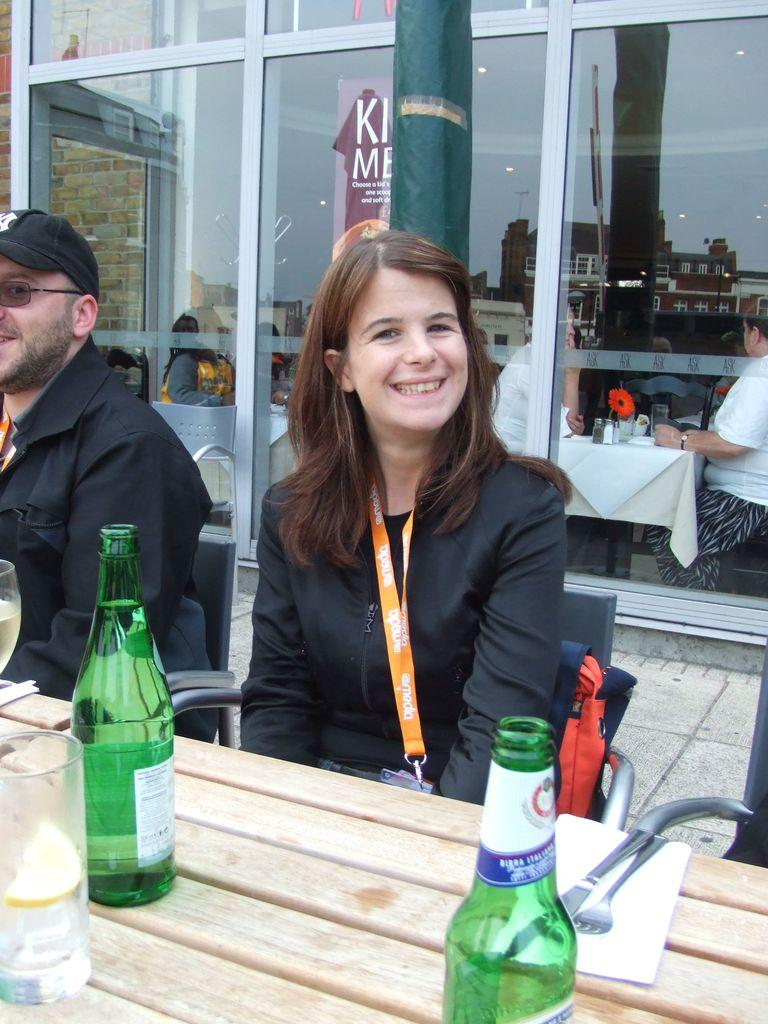What are the two people in the image doing? The woman and man in the image are sitting. Where are they sitting? They are sitting in front of a table. What can be seen on the table in the image? There are bottles on the table. What type of pail is visible in the image? There is no pail present in the image. How many balls are being juggled by the woman in the image? There are no balls or any indication of juggling in the image. What type of seed is being planted by the man in the image? There is no seed or planting activity depicted in the image. 